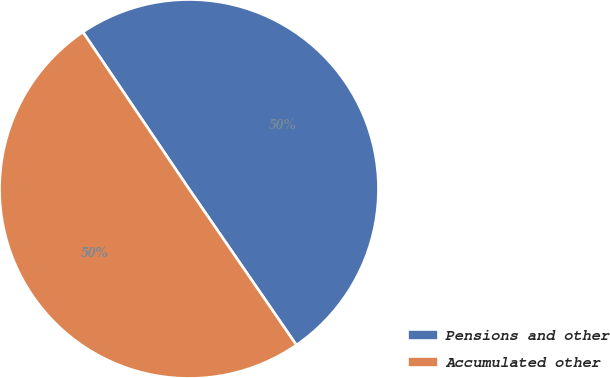Convert chart. <chart><loc_0><loc_0><loc_500><loc_500><pie_chart><fcel>Pensions and other<fcel>Accumulated other<nl><fcel>49.87%<fcel>50.13%<nl></chart> 